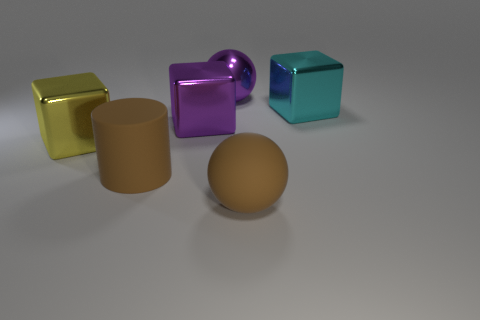Do the matte ball and the big rubber cylinder have the same color?
Make the answer very short. Yes. The big cube that is to the right of the large ball in front of the big yellow block is what color?
Your response must be concise. Cyan. Are there any rubber objects that have the same color as the big matte ball?
Your answer should be very brief. Yes. How many rubber things are either big brown things or yellow cubes?
Provide a succinct answer. 2. Are there any big brown things made of the same material as the brown ball?
Provide a short and direct response. Yes. What number of large objects are both in front of the big cyan metallic thing and on the right side of the purple metal cube?
Ensure brevity in your answer.  1. Is the number of big purple metal objects left of the brown cylinder less than the number of brown matte balls to the right of the large yellow thing?
Your answer should be compact. Yes. Is the shape of the cyan shiny thing the same as the big yellow object?
Ensure brevity in your answer.  Yes. How many other objects are there of the same size as the brown cylinder?
Your answer should be compact. 5. How many things are big cyan metallic things behind the brown matte sphere or objects behind the cylinder?
Give a very brief answer. 4. 